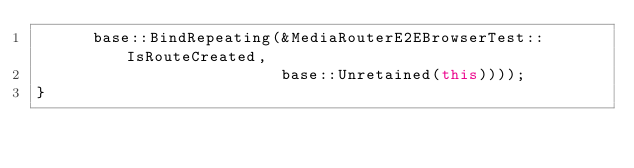<code> <loc_0><loc_0><loc_500><loc_500><_C++_>      base::BindRepeating(&MediaRouterE2EBrowserTest::IsRouteCreated,
                          base::Unretained(this))));
}
</code> 